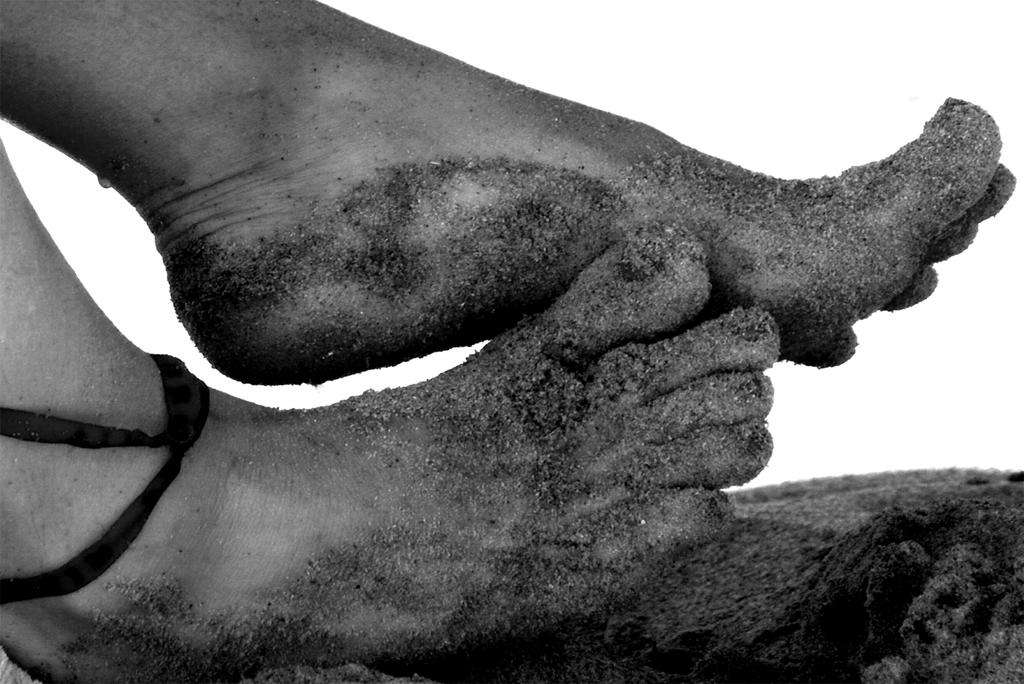What body part is visible in the middle of the image? There are human legs in the middle of the image. What is covering the human legs? Sand is present on the human legs. What type of pencil can be seen in the image? There is no pencil present in the image. What is the income of the person whose legs are in the image? The income of the person cannot be determined from the image. 